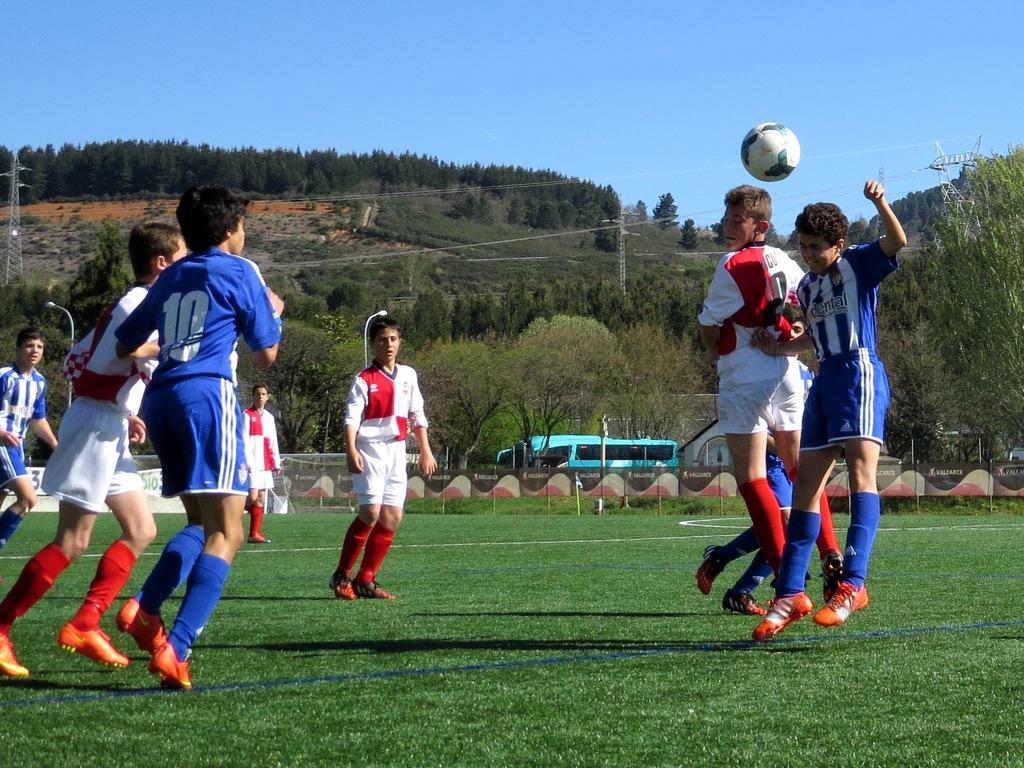In one or two sentences, can you explain what this image depicts? In the background we can see the sky, trees. In this picture we can see transmission poles and wires. We can see children playing in the ground. We can see a ball in the air. We can see fence and the wall. At the bottom portion of the picture we can see green grass. 